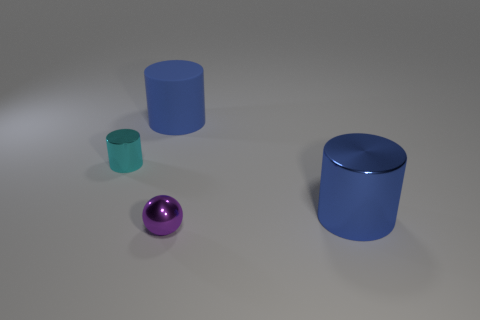Subtract all cyan spheres. Subtract all green cylinders. How many spheres are left? 1 Subtract all green cylinders. How many red balls are left? 0 Add 3 big browns. How many big things exist? 0 Subtract all purple spheres. Subtract all shiny things. How many objects are left? 0 Add 2 big cylinders. How many big cylinders are left? 4 Add 4 gray cylinders. How many gray cylinders exist? 4 Add 2 small cyan objects. How many objects exist? 6 Subtract all cyan cylinders. How many cylinders are left? 2 Subtract all metal cylinders. How many cylinders are left? 1 Subtract 0 blue balls. How many objects are left? 4 